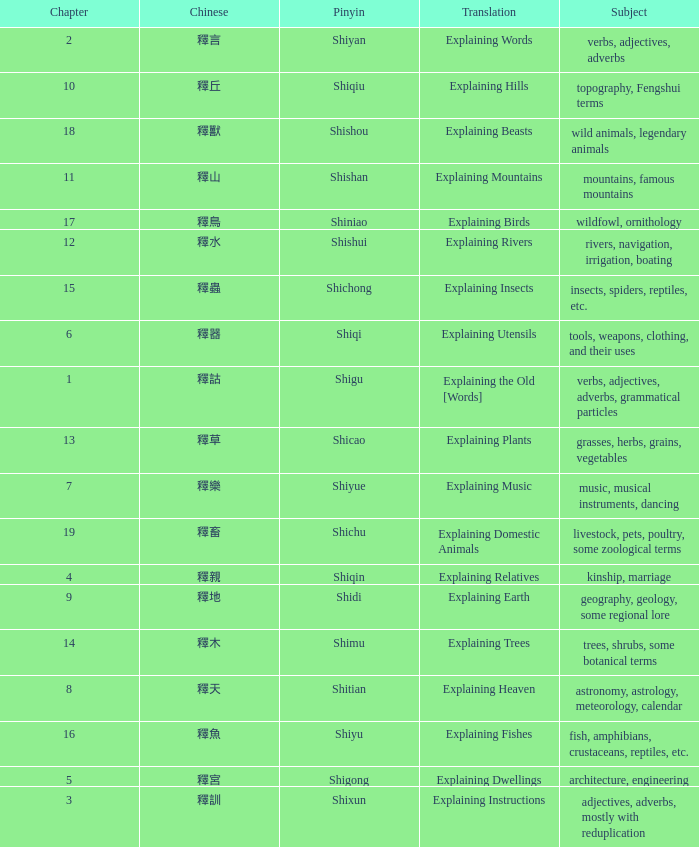Name the chapter with chinese of 釋水 12.0. 